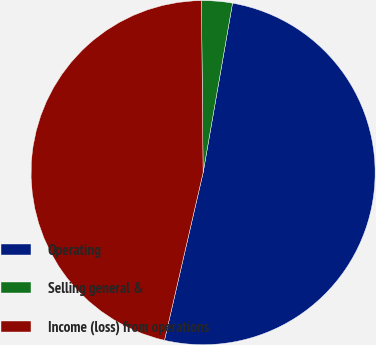Convert chart to OTSL. <chart><loc_0><loc_0><loc_500><loc_500><pie_chart><fcel>Operating<fcel>Selling general &<fcel>Income (loss) from operations<nl><fcel>50.87%<fcel>2.89%<fcel>46.24%<nl></chart> 